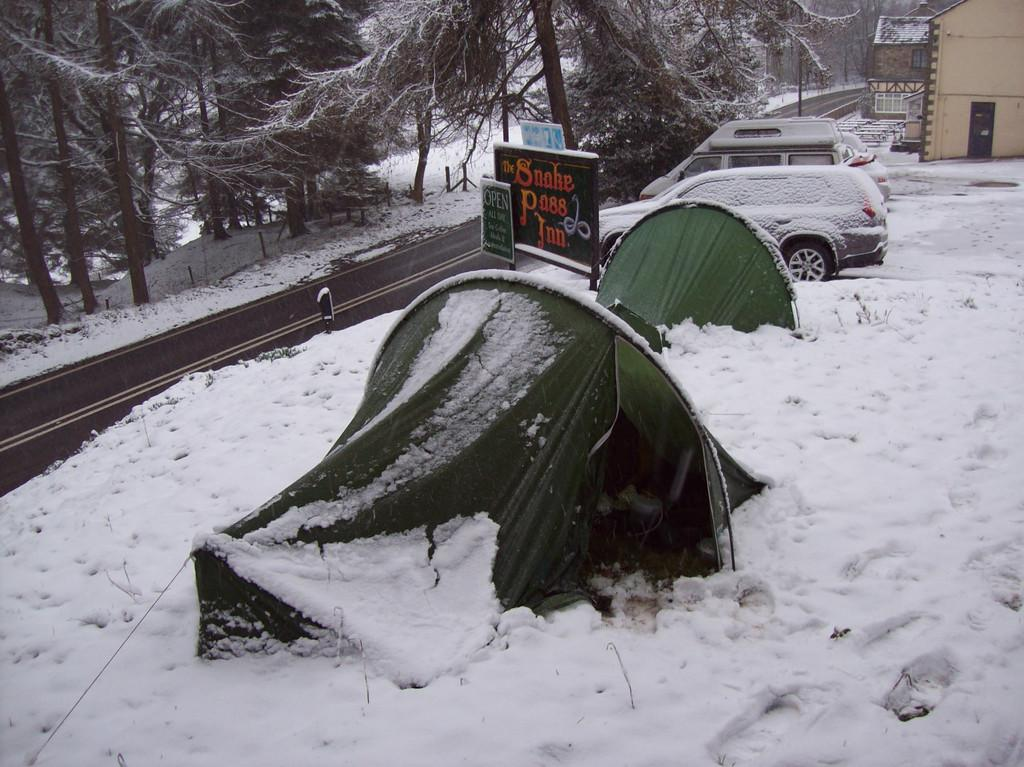Provide a one-sentence caption for the provided image. A sign in the snow stating that The Snake Pass In is Open. 